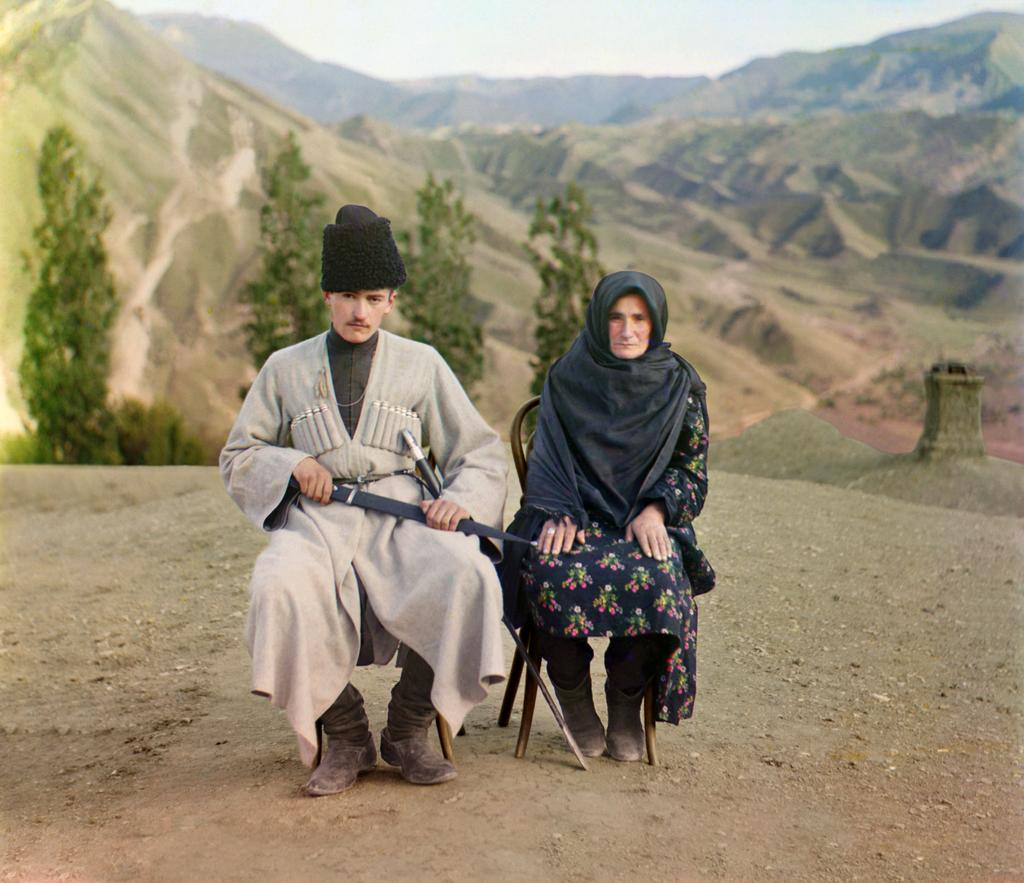How many people are in the image? There are two people in the image, a woman and a man. What are the positions of the woman and man in the image? Both the woman and man are sitting on chairs. What is the man holding in the image? The man is holding a weapon. What can be seen at the bottom of the image? There is a ground visible at the bottom of the image. What is visible in the background of the image? Hills, trees, and the sky are visible in the background of the image. What type of plantation can be seen in the image? There is no plantation present in the image. How many shelves are visible in the image? There are no shelves present in the image. 